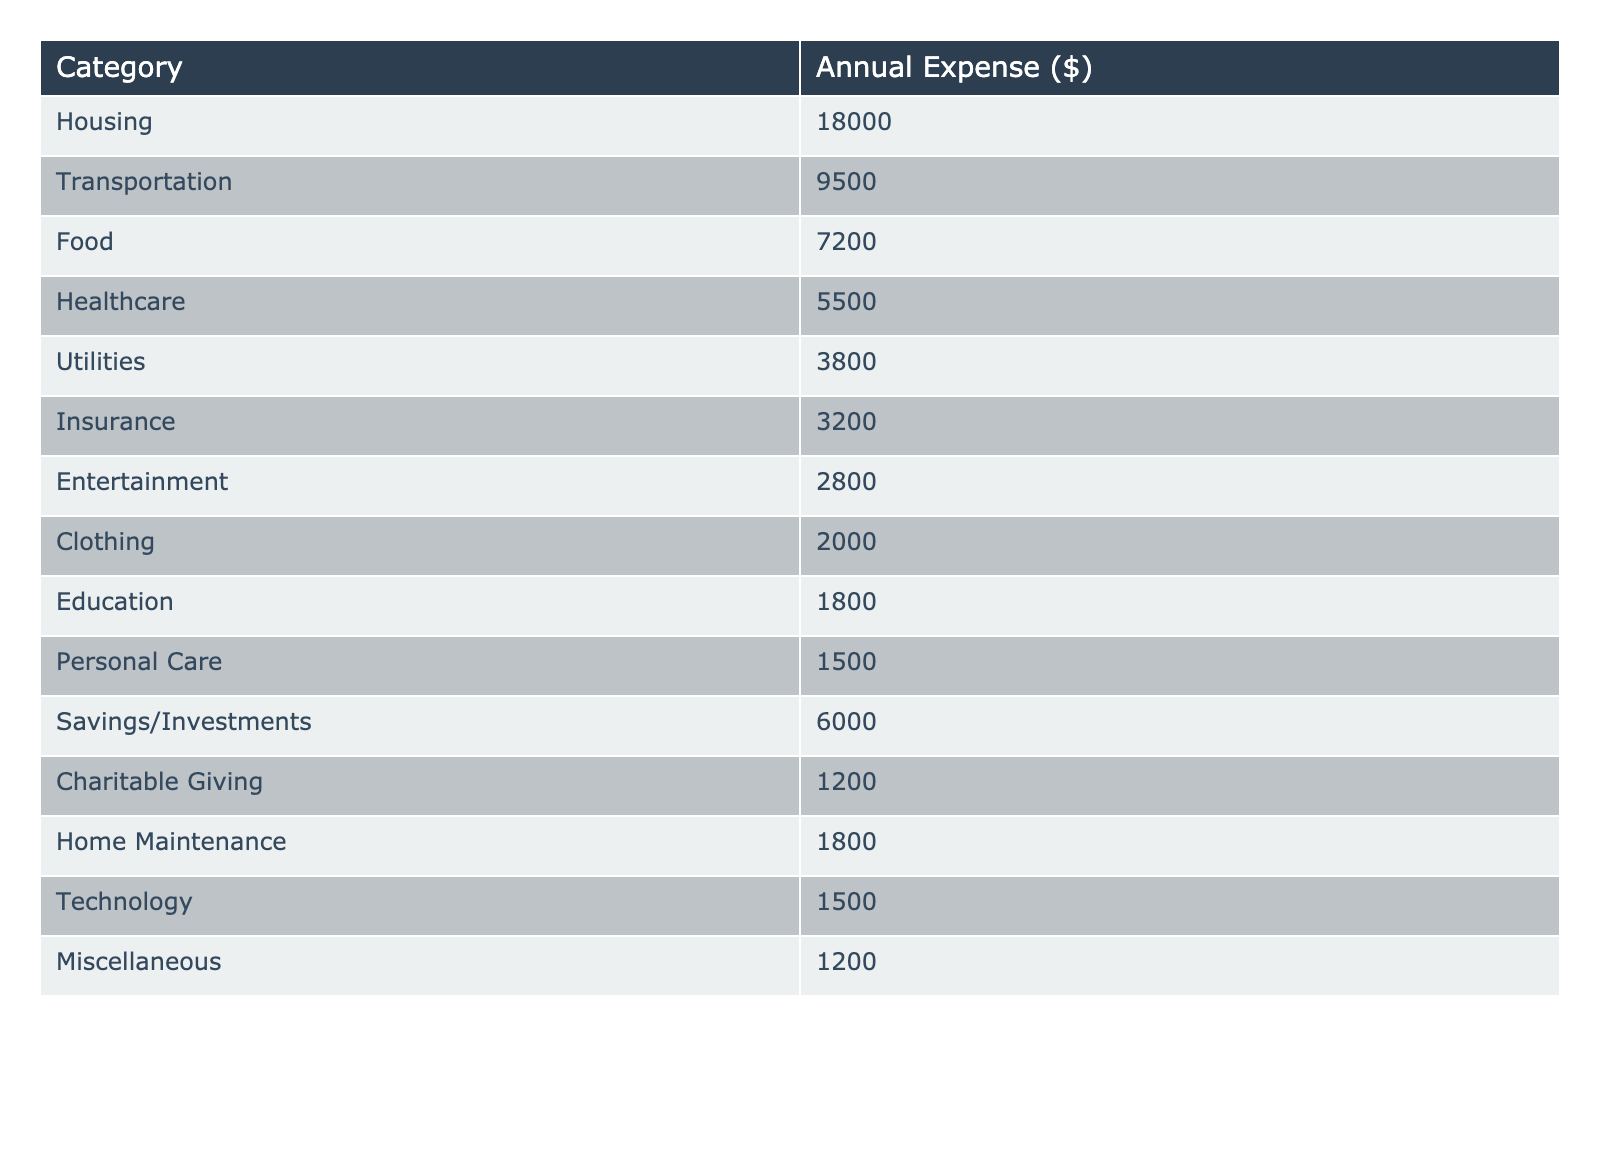What is the total annual expense for a middle-class household? To find the total annual expense, we sum all the values in the "Annual Expense" column: 18000 + 9500 + 7200 + 5500 + 3800 + 3200 + 2800 + 2000 + 1800 + 1500 + 6000 + 1200 + 1800 + 1500 + 1200 = 44100
Answer: 44100 Which category has the highest annual expense? By reviewing the "Annual Expense" column, we see that Housing has the highest value at 18000, while all other categories have lower expenses.
Answer: Housing What is the total spending on Healthcare and Education combined? We add the expenses for Healthcare and Education: Healthcare is 5500 and Education is 1800. So, the sum is 5500 + 1800 = 7300.
Answer: 7300 Is the annual expense for Transportation greater than the expense for Food? Transportation is 9500, and Food is 7200. Since 9500 is greater than 7200, the statement is true.
Answer: Yes What percentage of the total expenses is spent on Savings/Investments? First, we calculate the total expenses which is 44100. Then, Savings/Investments is 6000. To find the percentage, divide 6000 by 44100 and multiply by 100, which gives (6000 / 44100) * 100 ≈ 13.6%.
Answer: 13.6% What are the combined annual expenses for Clothing, Personal Care, and Charitable Giving? The annual expenses for these categories are Clothing: 2000, Personal Care: 1500, and Charitable Giving: 1200. We add them up: 2000 + 1500 + 1200 = 4700.
Answer: 4700 Are the expenses for Utilities and Insurance more than the total expenses for Entertainment and Technology combined? Utilities is 3800 and Insurance is 3200, summing these gives 3800 + 3200 = 7000. Entertainment is 2800 and Technology is 1500, so Entertainment + Technology = 2800 + 1500 = 4300. Since 7000 is greater than 4300, the statement is true.
Answer: Yes What is the least amount spent on any single category? Reviewing the expenses, the least amount is located in the "Clothing" category, which shows an annual expense of 2000.
Answer: 2000 